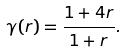Convert formula to latex. <formula><loc_0><loc_0><loc_500><loc_500>\gamma ( r ) = \frac { 1 + 4 r } { 1 + r } .</formula> 